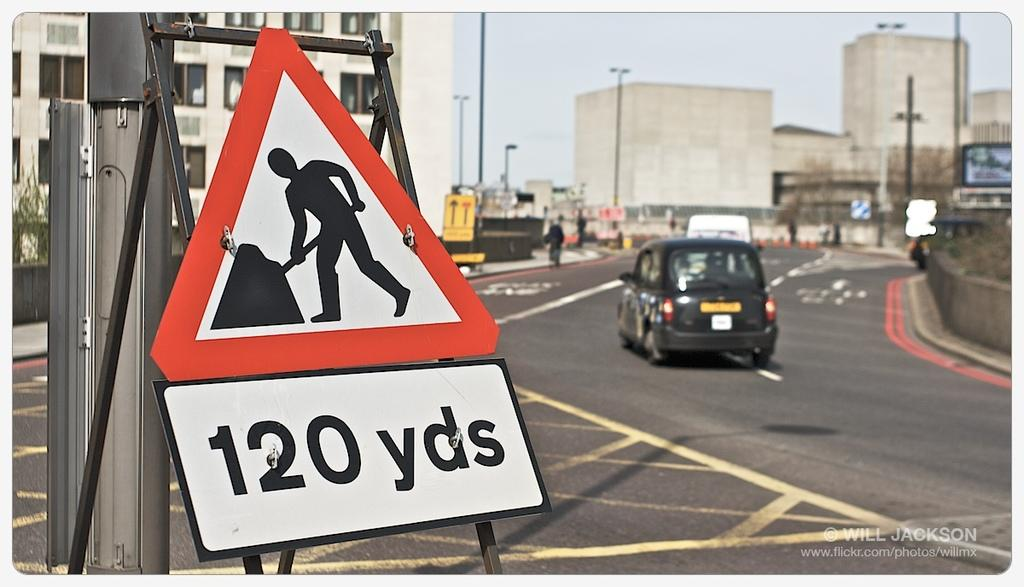<image>
Create a compact narrative representing the image presented. Triangular sign that has a picture of a man working and says 120 yards. along is a car on the road. 